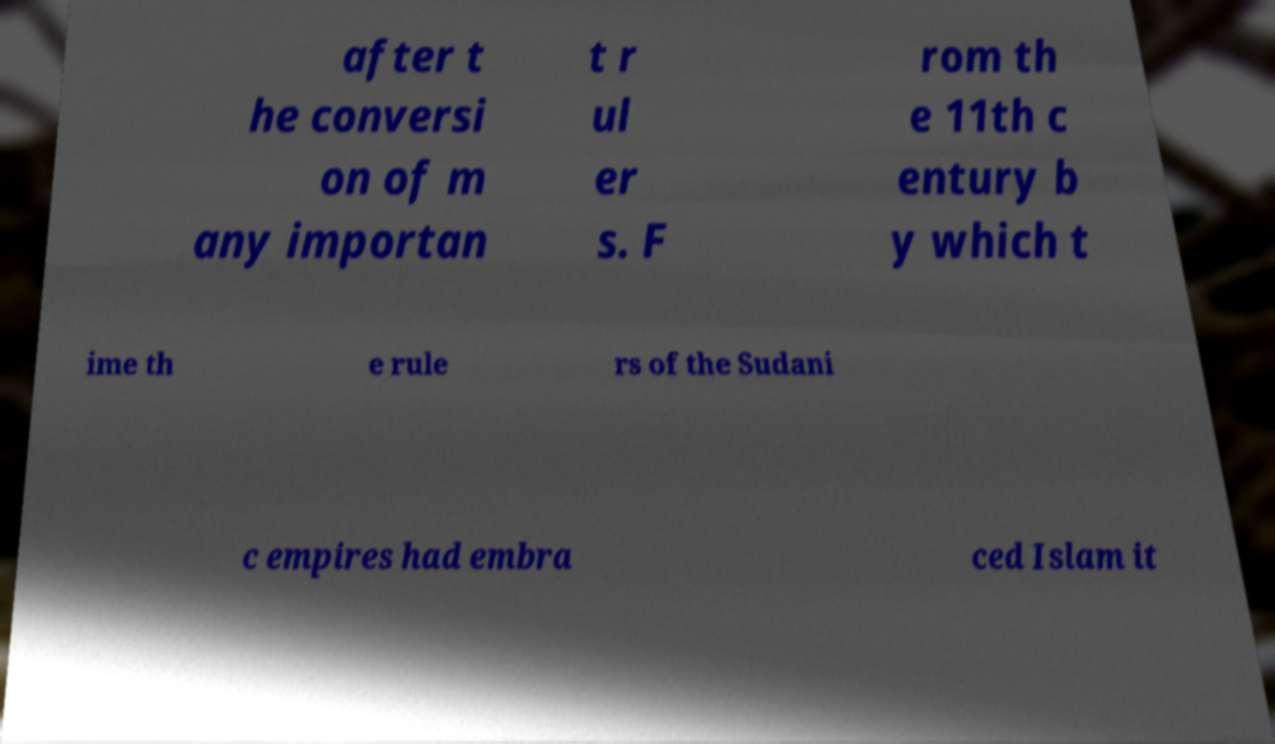For documentation purposes, I need the text within this image transcribed. Could you provide that? after t he conversi on of m any importan t r ul er s. F rom th e 11th c entury b y which t ime th e rule rs of the Sudani c empires had embra ced Islam it 